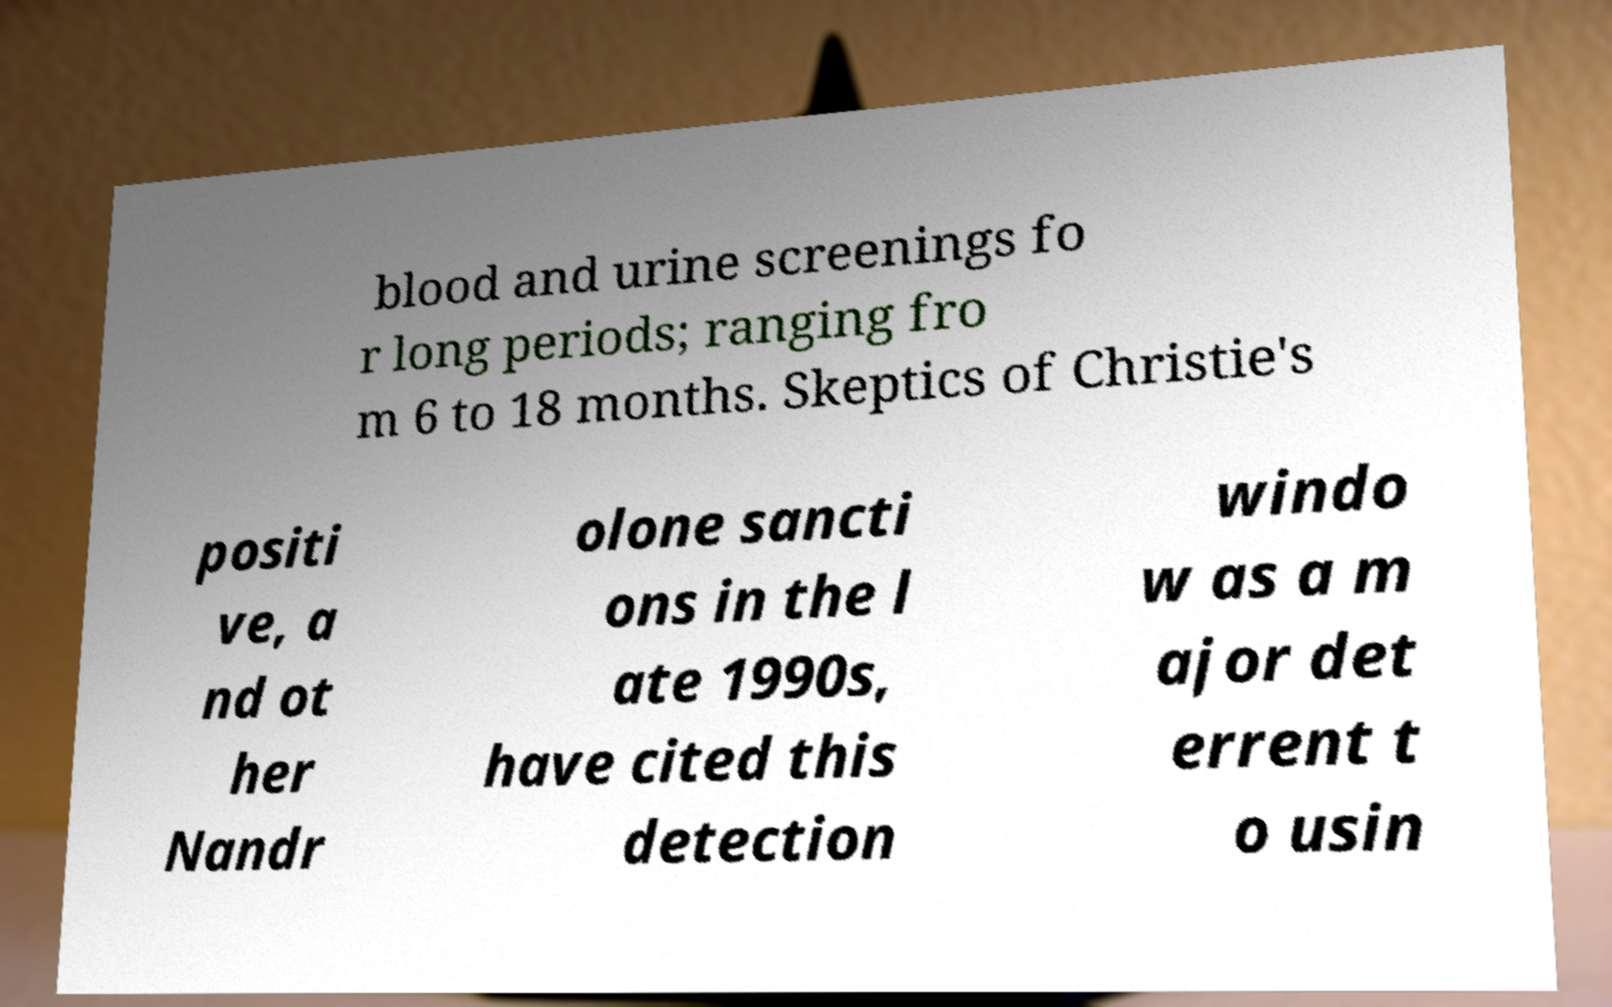Could you assist in decoding the text presented in this image and type it out clearly? blood and urine screenings fo r long periods; ranging fro m 6 to 18 months. Skeptics of Christie's positi ve, a nd ot her Nandr olone sancti ons in the l ate 1990s, have cited this detection windo w as a m ajor det errent t o usin 